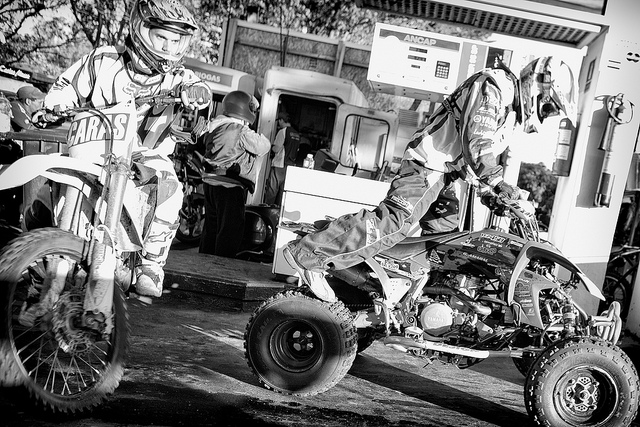Identify the text contained in this image. ANCAP CARAS 